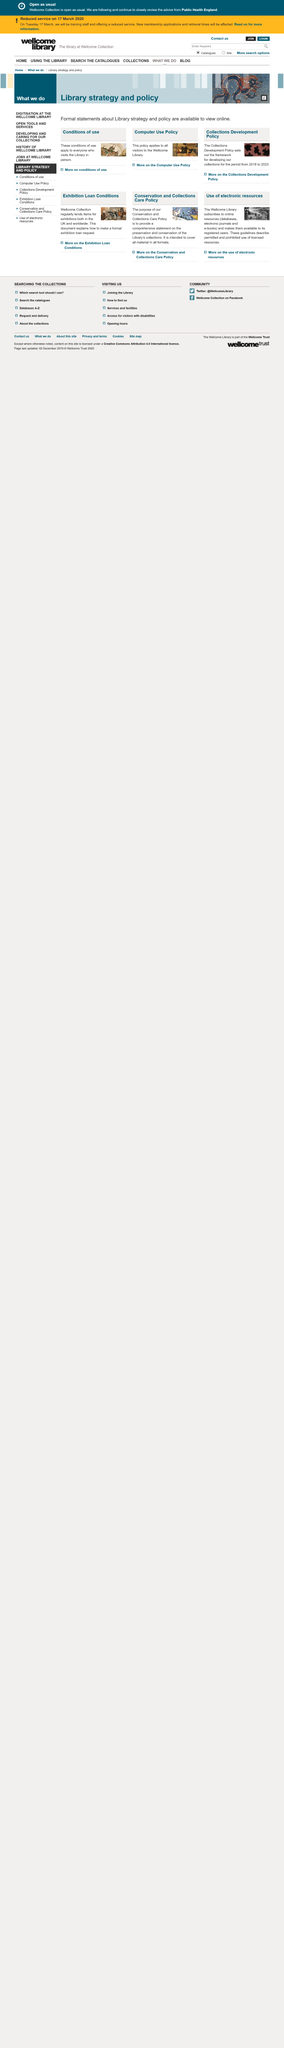Indicate a few pertinent items in this graphic. The Wellcome Library is mentioned in the text. How many apostrophes are in the text? There are 1 apostrophe in the text. The library subscribes to various online resources, including databases, electronic journals, and e-books, which provide access to a wealth of information. 